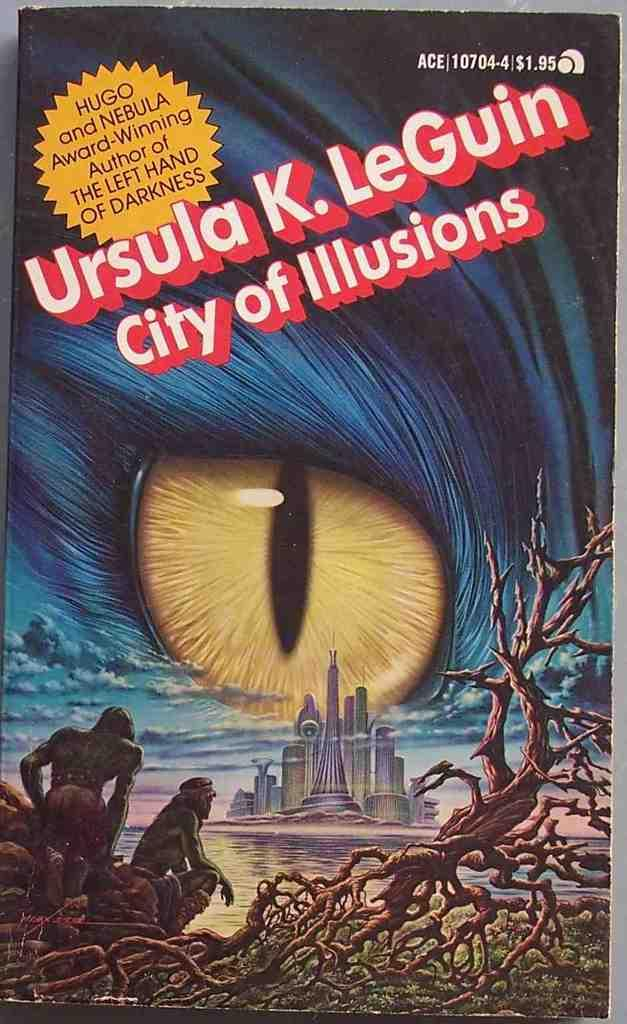<image>
Provide a brief description of the given image. Ursula K. LeGuin's book has a big eye on the cover and sells for $1.95. 